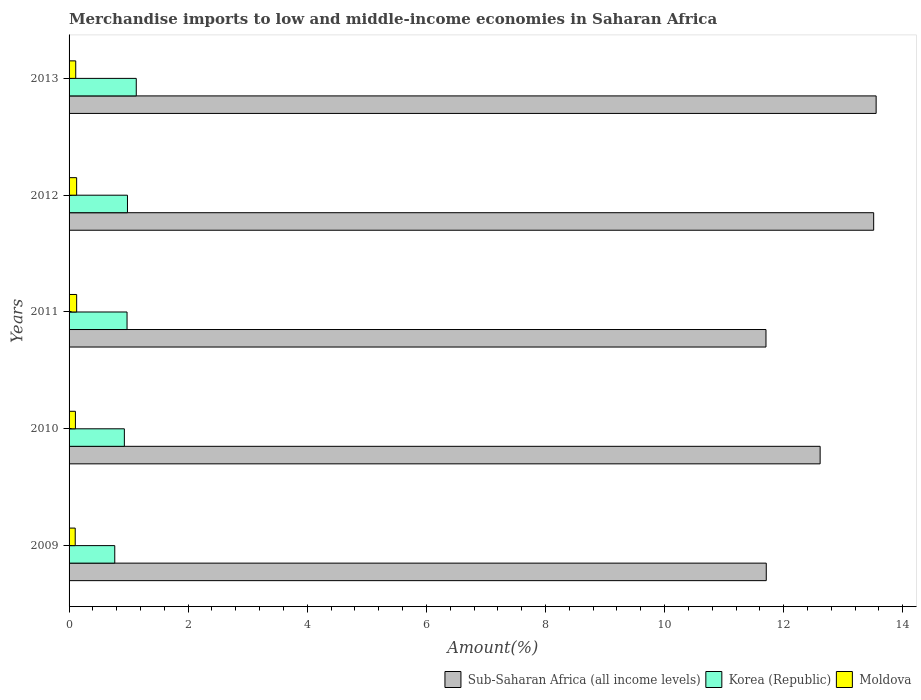How many different coloured bars are there?
Offer a very short reply. 3. Are the number of bars on each tick of the Y-axis equal?
Offer a very short reply. Yes. How many bars are there on the 3rd tick from the top?
Keep it short and to the point. 3. How many bars are there on the 4th tick from the bottom?
Give a very brief answer. 3. What is the label of the 3rd group of bars from the top?
Your response must be concise. 2011. In how many cases, is the number of bars for a given year not equal to the number of legend labels?
Provide a succinct answer. 0. What is the percentage of amount earned from merchandise imports in Moldova in 2011?
Provide a short and direct response. 0.13. Across all years, what is the maximum percentage of amount earned from merchandise imports in Sub-Saharan Africa (all income levels)?
Your answer should be compact. 13.55. Across all years, what is the minimum percentage of amount earned from merchandise imports in Korea (Republic)?
Make the answer very short. 0.77. In which year was the percentage of amount earned from merchandise imports in Sub-Saharan Africa (all income levels) maximum?
Your response must be concise. 2013. What is the total percentage of amount earned from merchandise imports in Sub-Saharan Africa (all income levels) in the graph?
Your answer should be compact. 63.09. What is the difference between the percentage of amount earned from merchandise imports in Korea (Republic) in 2010 and that in 2013?
Offer a very short reply. -0.2. What is the difference between the percentage of amount earned from merchandise imports in Moldova in 2010 and the percentage of amount earned from merchandise imports in Korea (Republic) in 2012?
Give a very brief answer. -0.87. What is the average percentage of amount earned from merchandise imports in Moldova per year?
Keep it short and to the point. 0.12. In the year 2012, what is the difference between the percentage of amount earned from merchandise imports in Sub-Saharan Africa (all income levels) and percentage of amount earned from merchandise imports in Moldova?
Your answer should be compact. 13.38. In how many years, is the percentage of amount earned from merchandise imports in Moldova greater than 4 %?
Your answer should be very brief. 0. What is the ratio of the percentage of amount earned from merchandise imports in Moldova in 2010 to that in 2013?
Provide a succinct answer. 0.95. Is the percentage of amount earned from merchandise imports in Moldova in 2010 less than that in 2013?
Your answer should be compact. Yes. Is the difference between the percentage of amount earned from merchandise imports in Sub-Saharan Africa (all income levels) in 2011 and 2013 greater than the difference between the percentage of amount earned from merchandise imports in Moldova in 2011 and 2013?
Offer a terse response. No. What is the difference between the highest and the second highest percentage of amount earned from merchandise imports in Sub-Saharan Africa (all income levels)?
Make the answer very short. 0.04. What is the difference between the highest and the lowest percentage of amount earned from merchandise imports in Sub-Saharan Africa (all income levels)?
Provide a short and direct response. 1.85. What does the 2nd bar from the top in 2009 represents?
Provide a short and direct response. Korea (Republic). What does the 2nd bar from the bottom in 2013 represents?
Keep it short and to the point. Korea (Republic). How many bars are there?
Provide a short and direct response. 15. Are all the bars in the graph horizontal?
Offer a terse response. Yes. What is the difference between two consecutive major ticks on the X-axis?
Offer a terse response. 2. Does the graph contain grids?
Keep it short and to the point. No. Where does the legend appear in the graph?
Offer a very short reply. Bottom right. How many legend labels are there?
Offer a very short reply. 3. How are the legend labels stacked?
Offer a terse response. Horizontal. What is the title of the graph?
Your answer should be compact. Merchandise imports to low and middle-income economies in Saharan Africa. Does "Congo (Democratic)" appear as one of the legend labels in the graph?
Your answer should be very brief. No. What is the label or title of the X-axis?
Your answer should be compact. Amount(%). What is the Amount(%) in Sub-Saharan Africa (all income levels) in 2009?
Your response must be concise. 11.71. What is the Amount(%) of Korea (Republic) in 2009?
Give a very brief answer. 0.77. What is the Amount(%) in Moldova in 2009?
Your answer should be very brief. 0.1. What is the Amount(%) of Sub-Saharan Africa (all income levels) in 2010?
Ensure brevity in your answer.  12.61. What is the Amount(%) of Korea (Republic) in 2010?
Provide a short and direct response. 0.93. What is the Amount(%) of Moldova in 2010?
Give a very brief answer. 0.11. What is the Amount(%) in Sub-Saharan Africa (all income levels) in 2011?
Offer a very short reply. 11.7. What is the Amount(%) in Korea (Republic) in 2011?
Provide a succinct answer. 0.97. What is the Amount(%) in Moldova in 2011?
Your response must be concise. 0.13. What is the Amount(%) of Sub-Saharan Africa (all income levels) in 2012?
Provide a succinct answer. 13.51. What is the Amount(%) in Korea (Republic) in 2012?
Ensure brevity in your answer.  0.98. What is the Amount(%) in Moldova in 2012?
Your answer should be compact. 0.13. What is the Amount(%) in Sub-Saharan Africa (all income levels) in 2013?
Provide a short and direct response. 13.55. What is the Amount(%) of Korea (Republic) in 2013?
Your response must be concise. 1.13. What is the Amount(%) of Moldova in 2013?
Keep it short and to the point. 0.11. Across all years, what is the maximum Amount(%) of Sub-Saharan Africa (all income levels)?
Provide a succinct answer. 13.55. Across all years, what is the maximum Amount(%) of Korea (Republic)?
Provide a succinct answer. 1.13. Across all years, what is the maximum Amount(%) in Moldova?
Your response must be concise. 0.13. Across all years, what is the minimum Amount(%) of Sub-Saharan Africa (all income levels)?
Offer a terse response. 11.7. Across all years, what is the minimum Amount(%) in Korea (Republic)?
Provide a succinct answer. 0.77. Across all years, what is the minimum Amount(%) in Moldova?
Offer a very short reply. 0.1. What is the total Amount(%) in Sub-Saharan Africa (all income levels) in the graph?
Provide a short and direct response. 63.09. What is the total Amount(%) in Korea (Republic) in the graph?
Provide a short and direct response. 4.78. What is the total Amount(%) in Moldova in the graph?
Provide a succinct answer. 0.58. What is the difference between the Amount(%) in Sub-Saharan Africa (all income levels) in 2009 and that in 2010?
Make the answer very short. -0.9. What is the difference between the Amount(%) of Korea (Republic) in 2009 and that in 2010?
Provide a succinct answer. -0.16. What is the difference between the Amount(%) of Moldova in 2009 and that in 2010?
Provide a short and direct response. -0. What is the difference between the Amount(%) of Sub-Saharan Africa (all income levels) in 2009 and that in 2011?
Your answer should be very brief. 0. What is the difference between the Amount(%) in Korea (Republic) in 2009 and that in 2011?
Make the answer very short. -0.21. What is the difference between the Amount(%) in Moldova in 2009 and that in 2011?
Your answer should be very brief. -0.02. What is the difference between the Amount(%) of Sub-Saharan Africa (all income levels) in 2009 and that in 2012?
Provide a succinct answer. -1.8. What is the difference between the Amount(%) in Korea (Republic) in 2009 and that in 2012?
Provide a short and direct response. -0.21. What is the difference between the Amount(%) of Moldova in 2009 and that in 2012?
Keep it short and to the point. -0.02. What is the difference between the Amount(%) of Sub-Saharan Africa (all income levels) in 2009 and that in 2013?
Keep it short and to the point. -1.84. What is the difference between the Amount(%) of Korea (Republic) in 2009 and that in 2013?
Offer a terse response. -0.36. What is the difference between the Amount(%) of Moldova in 2009 and that in 2013?
Make the answer very short. -0.01. What is the difference between the Amount(%) of Sub-Saharan Africa (all income levels) in 2010 and that in 2011?
Your response must be concise. 0.91. What is the difference between the Amount(%) of Korea (Republic) in 2010 and that in 2011?
Make the answer very short. -0.05. What is the difference between the Amount(%) of Moldova in 2010 and that in 2011?
Ensure brevity in your answer.  -0.02. What is the difference between the Amount(%) of Sub-Saharan Africa (all income levels) in 2010 and that in 2012?
Ensure brevity in your answer.  -0.9. What is the difference between the Amount(%) of Korea (Republic) in 2010 and that in 2012?
Keep it short and to the point. -0.05. What is the difference between the Amount(%) in Moldova in 2010 and that in 2012?
Your answer should be very brief. -0.02. What is the difference between the Amount(%) of Sub-Saharan Africa (all income levels) in 2010 and that in 2013?
Offer a terse response. -0.94. What is the difference between the Amount(%) in Korea (Republic) in 2010 and that in 2013?
Keep it short and to the point. -0.2. What is the difference between the Amount(%) of Moldova in 2010 and that in 2013?
Ensure brevity in your answer.  -0.01. What is the difference between the Amount(%) in Sub-Saharan Africa (all income levels) in 2011 and that in 2012?
Your answer should be compact. -1.81. What is the difference between the Amount(%) in Korea (Republic) in 2011 and that in 2012?
Your answer should be very brief. -0.01. What is the difference between the Amount(%) in Moldova in 2011 and that in 2012?
Offer a terse response. 0. What is the difference between the Amount(%) of Sub-Saharan Africa (all income levels) in 2011 and that in 2013?
Your answer should be very brief. -1.85. What is the difference between the Amount(%) of Korea (Republic) in 2011 and that in 2013?
Your response must be concise. -0.15. What is the difference between the Amount(%) in Moldova in 2011 and that in 2013?
Provide a short and direct response. 0.02. What is the difference between the Amount(%) in Sub-Saharan Africa (all income levels) in 2012 and that in 2013?
Offer a very short reply. -0.04. What is the difference between the Amount(%) of Korea (Republic) in 2012 and that in 2013?
Offer a very short reply. -0.15. What is the difference between the Amount(%) in Moldova in 2012 and that in 2013?
Provide a short and direct response. 0.02. What is the difference between the Amount(%) in Sub-Saharan Africa (all income levels) in 2009 and the Amount(%) in Korea (Republic) in 2010?
Your response must be concise. 10.78. What is the difference between the Amount(%) in Sub-Saharan Africa (all income levels) in 2009 and the Amount(%) in Moldova in 2010?
Provide a short and direct response. 11.6. What is the difference between the Amount(%) in Korea (Republic) in 2009 and the Amount(%) in Moldova in 2010?
Your response must be concise. 0.66. What is the difference between the Amount(%) in Sub-Saharan Africa (all income levels) in 2009 and the Amount(%) in Korea (Republic) in 2011?
Your answer should be compact. 10.73. What is the difference between the Amount(%) of Sub-Saharan Africa (all income levels) in 2009 and the Amount(%) of Moldova in 2011?
Keep it short and to the point. 11.58. What is the difference between the Amount(%) in Korea (Republic) in 2009 and the Amount(%) in Moldova in 2011?
Make the answer very short. 0.64. What is the difference between the Amount(%) in Sub-Saharan Africa (all income levels) in 2009 and the Amount(%) in Korea (Republic) in 2012?
Your response must be concise. 10.73. What is the difference between the Amount(%) of Sub-Saharan Africa (all income levels) in 2009 and the Amount(%) of Moldova in 2012?
Your answer should be compact. 11.58. What is the difference between the Amount(%) of Korea (Republic) in 2009 and the Amount(%) of Moldova in 2012?
Your answer should be very brief. 0.64. What is the difference between the Amount(%) in Sub-Saharan Africa (all income levels) in 2009 and the Amount(%) in Korea (Republic) in 2013?
Ensure brevity in your answer.  10.58. What is the difference between the Amount(%) of Sub-Saharan Africa (all income levels) in 2009 and the Amount(%) of Moldova in 2013?
Your response must be concise. 11.6. What is the difference between the Amount(%) of Korea (Republic) in 2009 and the Amount(%) of Moldova in 2013?
Provide a short and direct response. 0.66. What is the difference between the Amount(%) of Sub-Saharan Africa (all income levels) in 2010 and the Amount(%) of Korea (Republic) in 2011?
Your answer should be compact. 11.64. What is the difference between the Amount(%) of Sub-Saharan Africa (all income levels) in 2010 and the Amount(%) of Moldova in 2011?
Provide a short and direct response. 12.49. What is the difference between the Amount(%) of Korea (Republic) in 2010 and the Amount(%) of Moldova in 2011?
Your response must be concise. 0.8. What is the difference between the Amount(%) in Sub-Saharan Africa (all income levels) in 2010 and the Amount(%) in Korea (Republic) in 2012?
Your response must be concise. 11.63. What is the difference between the Amount(%) in Sub-Saharan Africa (all income levels) in 2010 and the Amount(%) in Moldova in 2012?
Ensure brevity in your answer.  12.49. What is the difference between the Amount(%) in Korea (Republic) in 2010 and the Amount(%) in Moldova in 2012?
Make the answer very short. 0.8. What is the difference between the Amount(%) of Sub-Saharan Africa (all income levels) in 2010 and the Amount(%) of Korea (Republic) in 2013?
Keep it short and to the point. 11.48. What is the difference between the Amount(%) of Sub-Saharan Africa (all income levels) in 2010 and the Amount(%) of Moldova in 2013?
Your response must be concise. 12.5. What is the difference between the Amount(%) of Korea (Republic) in 2010 and the Amount(%) of Moldova in 2013?
Make the answer very short. 0.82. What is the difference between the Amount(%) of Sub-Saharan Africa (all income levels) in 2011 and the Amount(%) of Korea (Republic) in 2012?
Provide a short and direct response. 10.72. What is the difference between the Amount(%) of Sub-Saharan Africa (all income levels) in 2011 and the Amount(%) of Moldova in 2012?
Your answer should be very brief. 11.58. What is the difference between the Amount(%) in Korea (Republic) in 2011 and the Amount(%) in Moldova in 2012?
Offer a very short reply. 0.85. What is the difference between the Amount(%) of Sub-Saharan Africa (all income levels) in 2011 and the Amount(%) of Korea (Republic) in 2013?
Provide a short and direct response. 10.57. What is the difference between the Amount(%) of Sub-Saharan Africa (all income levels) in 2011 and the Amount(%) of Moldova in 2013?
Provide a succinct answer. 11.59. What is the difference between the Amount(%) of Korea (Republic) in 2011 and the Amount(%) of Moldova in 2013?
Your response must be concise. 0.86. What is the difference between the Amount(%) of Sub-Saharan Africa (all income levels) in 2012 and the Amount(%) of Korea (Republic) in 2013?
Ensure brevity in your answer.  12.38. What is the difference between the Amount(%) of Sub-Saharan Africa (all income levels) in 2012 and the Amount(%) of Moldova in 2013?
Offer a terse response. 13.4. What is the difference between the Amount(%) in Korea (Republic) in 2012 and the Amount(%) in Moldova in 2013?
Keep it short and to the point. 0.87. What is the average Amount(%) of Sub-Saharan Africa (all income levels) per year?
Make the answer very short. 12.62. What is the average Amount(%) in Korea (Republic) per year?
Provide a short and direct response. 0.96. What is the average Amount(%) in Moldova per year?
Your answer should be compact. 0.12. In the year 2009, what is the difference between the Amount(%) of Sub-Saharan Africa (all income levels) and Amount(%) of Korea (Republic)?
Make the answer very short. 10.94. In the year 2009, what is the difference between the Amount(%) in Sub-Saharan Africa (all income levels) and Amount(%) in Moldova?
Provide a succinct answer. 11.6. In the year 2009, what is the difference between the Amount(%) of Korea (Republic) and Amount(%) of Moldova?
Your response must be concise. 0.66. In the year 2010, what is the difference between the Amount(%) in Sub-Saharan Africa (all income levels) and Amount(%) in Korea (Republic)?
Your response must be concise. 11.68. In the year 2010, what is the difference between the Amount(%) of Sub-Saharan Africa (all income levels) and Amount(%) of Moldova?
Provide a short and direct response. 12.51. In the year 2010, what is the difference between the Amount(%) of Korea (Republic) and Amount(%) of Moldova?
Your response must be concise. 0.82. In the year 2011, what is the difference between the Amount(%) in Sub-Saharan Africa (all income levels) and Amount(%) in Korea (Republic)?
Your response must be concise. 10.73. In the year 2011, what is the difference between the Amount(%) of Sub-Saharan Africa (all income levels) and Amount(%) of Moldova?
Offer a terse response. 11.58. In the year 2011, what is the difference between the Amount(%) in Korea (Republic) and Amount(%) in Moldova?
Provide a short and direct response. 0.85. In the year 2012, what is the difference between the Amount(%) in Sub-Saharan Africa (all income levels) and Amount(%) in Korea (Republic)?
Ensure brevity in your answer.  12.53. In the year 2012, what is the difference between the Amount(%) in Sub-Saharan Africa (all income levels) and Amount(%) in Moldova?
Your response must be concise. 13.38. In the year 2012, what is the difference between the Amount(%) of Korea (Republic) and Amount(%) of Moldova?
Keep it short and to the point. 0.85. In the year 2013, what is the difference between the Amount(%) in Sub-Saharan Africa (all income levels) and Amount(%) in Korea (Republic)?
Your response must be concise. 12.42. In the year 2013, what is the difference between the Amount(%) of Sub-Saharan Africa (all income levels) and Amount(%) of Moldova?
Provide a succinct answer. 13.44. In the year 2013, what is the difference between the Amount(%) of Korea (Republic) and Amount(%) of Moldova?
Your response must be concise. 1.02. What is the ratio of the Amount(%) in Sub-Saharan Africa (all income levels) in 2009 to that in 2010?
Give a very brief answer. 0.93. What is the ratio of the Amount(%) of Korea (Republic) in 2009 to that in 2010?
Offer a terse response. 0.83. What is the ratio of the Amount(%) in Moldova in 2009 to that in 2010?
Provide a succinct answer. 0.97. What is the ratio of the Amount(%) of Korea (Republic) in 2009 to that in 2011?
Offer a terse response. 0.79. What is the ratio of the Amount(%) in Moldova in 2009 to that in 2011?
Give a very brief answer. 0.81. What is the ratio of the Amount(%) of Sub-Saharan Africa (all income levels) in 2009 to that in 2012?
Provide a succinct answer. 0.87. What is the ratio of the Amount(%) in Korea (Republic) in 2009 to that in 2012?
Keep it short and to the point. 0.78. What is the ratio of the Amount(%) in Moldova in 2009 to that in 2012?
Make the answer very short. 0.81. What is the ratio of the Amount(%) in Sub-Saharan Africa (all income levels) in 2009 to that in 2013?
Your answer should be compact. 0.86. What is the ratio of the Amount(%) in Korea (Republic) in 2009 to that in 2013?
Provide a short and direct response. 0.68. What is the ratio of the Amount(%) of Moldova in 2009 to that in 2013?
Ensure brevity in your answer.  0.92. What is the ratio of the Amount(%) of Sub-Saharan Africa (all income levels) in 2010 to that in 2011?
Provide a short and direct response. 1.08. What is the ratio of the Amount(%) in Korea (Republic) in 2010 to that in 2011?
Offer a very short reply. 0.95. What is the ratio of the Amount(%) in Moldova in 2010 to that in 2011?
Your answer should be very brief. 0.84. What is the ratio of the Amount(%) in Sub-Saharan Africa (all income levels) in 2010 to that in 2012?
Ensure brevity in your answer.  0.93. What is the ratio of the Amount(%) in Korea (Republic) in 2010 to that in 2012?
Provide a succinct answer. 0.95. What is the ratio of the Amount(%) of Moldova in 2010 to that in 2012?
Your answer should be very brief. 0.84. What is the ratio of the Amount(%) of Sub-Saharan Africa (all income levels) in 2010 to that in 2013?
Make the answer very short. 0.93. What is the ratio of the Amount(%) in Korea (Republic) in 2010 to that in 2013?
Your answer should be compact. 0.82. What is the ratio of the Amount(%) in Moldova in 2010 to that in 2013?
Give a very brief answer. 0.95. What is the ratio of the Amount(%) in Sub-Saharan Africa (all income levels) in 2011 to that in 2012?
Keep it short and to the point. 0.87. What is the ratio of the Amount(%) in Korea (Republic) in 2011 to that in 2012?
Offer a terse response. 0.99. What is the ratio of the Amount(%) of Moldova in 2011 to that in 2012?
Provide a short and direct response. 1. What is the ratio of the Amount(%) of Sub-Saharan Africa (all income levels) in 2011 to that in 2013?
Offer a terse response. 0.86. What is the ratio of the Amount(%) in Korea (Republic) in 2011 to that in 2013?
Ensure brevity in your answer.  0.86. What is the ratio of the Amount(%) of Moldova in 2011 to that in 2013?
Your answer should be very brief. 1.14. What is the ratio of the Amount(%) in Korea (Republic) in 2012 to that in 2013?
Make the answer very short. 0.87. What is the ratio of the Amount(%) of Moldova in 2012 to that in 2013?
Provide a succinct answer. 1.14. What is the difference between the highest and the second highest Amount(%) in Sub-Saharan Africa (all income levels)?
Give a very brief answer. 0.04. What is the difference between the highest and the second highest Amount(%) in Korea (Republic)?
Your answer should be compact. 0.15. What is the difference between the highest and the second highest Amount(%) of Moldova?
Ensure brevity in your answer.  0. What is the difference between the highest and the lowest Amount(%) in Sub-Saharan Africa (all income levels)?
Make the answer very short. 1.85. What is the difference between the highest and the lowest Amount(%) in Korea (Republic)?
Your answer should be compact. 0.36. What is the difference between the highest and the lowest Amount(%) in Moldova?
Your response must be concise. 0.02. 